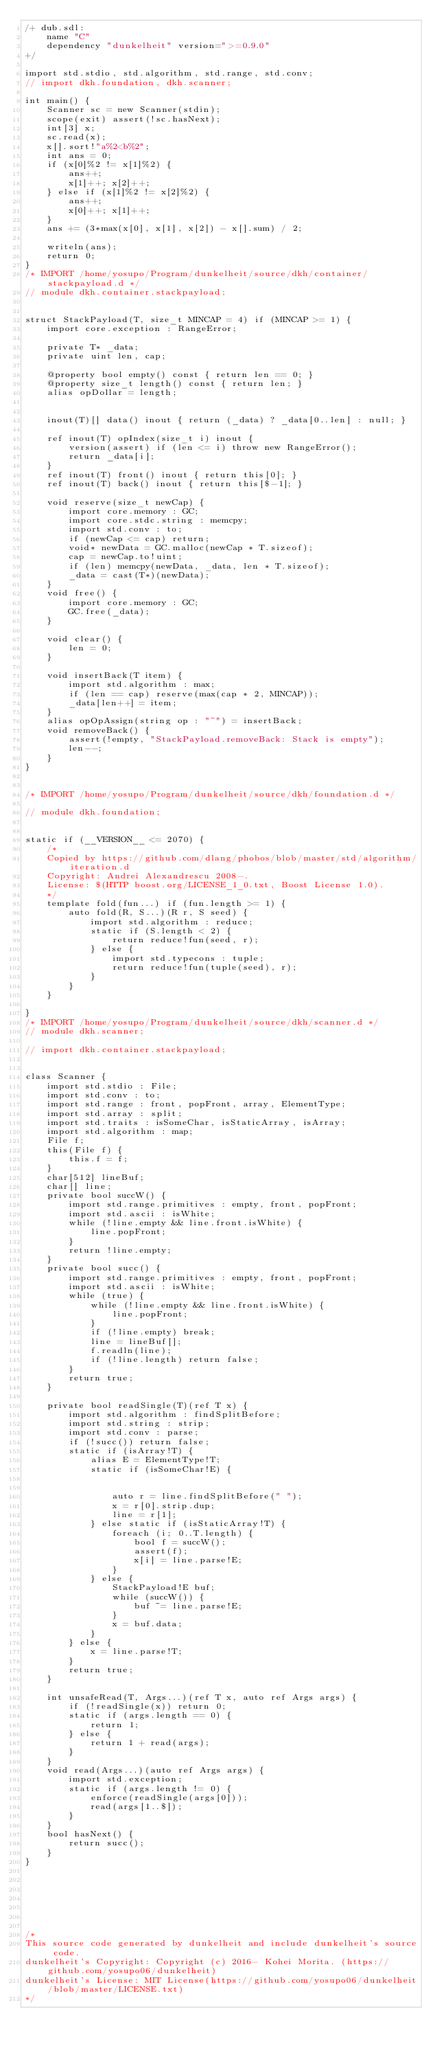Convert code to text. <code><loc_0><loc_0><loc_500><loc_500><_D_>/+ dub.sdl:
    name "C"
    dependency "dunkelheit" version=">=0.9.0"
+/

import std.stdio, std.algorithm, std.range, std.conv;
// import dkh.foundation, dkh.scanner;

int main() {
    Scanner sc = new Scanner(stdin);
    scope(exit) assert(!sc.hasNext);
    int[3] x;
    sc.read(x);
    x[].sort!"a%2<b%2";
    int ans = 0;
    if (x[0]%2 != x[1]%2) {
        ans++;
        x[1]++; x[2]++;
    } else if (x[1]%2 != x[2]%2) {
        ans++;
        x[0]++; x[1]++;
    }
    ans += (3*max(x[0], x[1], x[2]) - x[].sum) / 2;

    writeln(ans);
    return 0;
}
/* IMPORT /home/yosupo/Program/dunkelheit/source/dkh/container/stackpayload.d */
// module dkh.container.stackpayload;

 
struct StackPayload(T, size_t MINCAP = 4) if (MINCAP >= 1) {
    import core.exception : RangeError;

    private T* _data;
    private uint len, cap;

    @property bool empty() const { return len == 0; }
    @property size_t length() const { return len; }
    alias opDollar = length;

     
    inout(T)[] data() inout { return (_data) ? _data[0..len] : null; }
    
    ref inout(T) opIndex(size_t i) inout {
        version(assert) if (len <= i) throw new RangeError();
        return _data[i];
    }  
    ref inout(T) front() inout { return this[0]; }  
    ref inout(T) back() inout { return this[$-1]; }  

    void reserve(size_t newCap) {
        import core.memory : GC;
        import core.stdc.string : memcpy;
        import std.conv : to;
        if (newCap <= cap) return;
        void* newData = GC.malloc(newCap * T.sizeof);
        cap = newCap.to!uint;
        if (len) memcpy(newData, _data, len * T.sizeof);
        _data = cast(T*)(newData);
    }  
    void free() {
        import core.memory : GC;
        GC.free(_data);
    }  
     
    void clear() {
        len = 0;
    }

    void insertBack(T item) {
        import std.algorithm : max;
        if (len == cap) reserve(max(cap * 2, MINCAP));
        _data[len++] = item;
    }  
    alias opOpAssign(string op : "~") = insertBack;  
    void removeBack() {
        assert(!empty, "StackPayload.removeBack: Stack is empty");
        len--;
    }  
}

 
/* IMPORT /home/yosupo/Program/dunkelheit/source/dkh/foundation.d */
 
// module dkh.foundation;

 
static if (__VERSION__ <= 2070) {
    /*
    Copied by https://github.com/dlang/phobos/blob/master/std/algorithm/iteration.d
    Copyright: Andrei Alexandrescu 2008-.
    License: $(HTTP boost.org/LICENSE_1_0.txt, Boost License 1.0).
    */
    template fold(fun...) if (fun.length >= 1) {
        auto fold(R, S...)(R r, S seed) {
            import std.algorithm : reduce;
            static if (S.length < 2) {
                return reduce!fun(seed, r);
            } else {
                import std.typecons : tuple;
                return reduce!fun(tuple(seed), r);
            }
        }
    }
     
}
/* IMPORT /home/yosupo/Program/dunkelheit/source/dkh/scanner.d */
// module dkh.scanner;

// import dkh.container.stackpayload;

 
class Scanner {
    import std.stdio : File;
    import std.conv : to;
    import std.range : front, popFront, array, ElementType;
    import std.array : split;
    import std.traits : isSomeChar, isStaticArray, isArray; 
    import std.algorithm : map;
    File f;
    this(File f) {
        this.f = f;
    }
    char[512] lineBuf;
    char[] line;
    private bool succW() {
        import std.range.primitives : empty, front, popFront;
        import std.ascii : isWhite;
        while (!line.empty && line.front.isWhite) {
            line.popFront;
        }
        return !line.empty;
    }
    private bool succ() {
        import std.range.primitives : empty, front, popFront;
        import std.ascii : isWhite;
        while (true) {
            while (!line.empty && line.front.isWhite) {
                line.popFront;
            }
            if (!line.empty) break;
            line = lineBuf[];
            f.readln(line);
            if (!line.length) return false;
        }
        return true;
    }

    private bool readSingle(T)(ref T x) {
        import std.algorithm : findSplitBefore;
        import std.string : strip;
        import std.conv : parse;
        if (!succ()) return false;
        static if (isArray!T) {
            alias E = ElementType!T;
            static if (isSomeChar!E) {
                 
                 
                auto r = line.findSplitBefore(" ");
                x = r[0].strip.dup;
                line = r[1];
            } else static if (isStaticArray!T) {
                foreach (i; 0..T.length) {
                    bool f = succW();
                    assert(f);
                    x[i] = line.parse!E;
                }
            } else {
                StackPayload!E buf;
                while (succW()) {
                    buf ~= line.parse!E;
                }
                x = buf.data;
            }
        } else {
            x = line.parse!T;
        }
        return true;
    }

    int unsafeRead(T, Args...)(ref T x, auto ref Args args) {
        if (!readSingle(x)) return 0;
        static if (args.length == 0) {
            return 1;
        } else {
            return 1 + read(args);
        }
    }
    void read(Args...)(auto ref Args args) {
        import std.exception;
        static if (args.length != 0) {
            enforce(readSingle(args[0]));
            read(args[1..$]);
        }
    }
    bool hasNext() {
        return succ();
    }
}


 
 

 

/*
This source code generated by dunkelheit and include dunkelheit's source code.
dunkelheit's Copyright: Copyright (c) 2016- Kohei Morita. (https://github.com/yosupo06/dunkelheit)
dunkelheit's License: MIT License(https://github.com/yosupo06/dunkelheit/blob/master/LICENSE.txt)
*/
</code> 